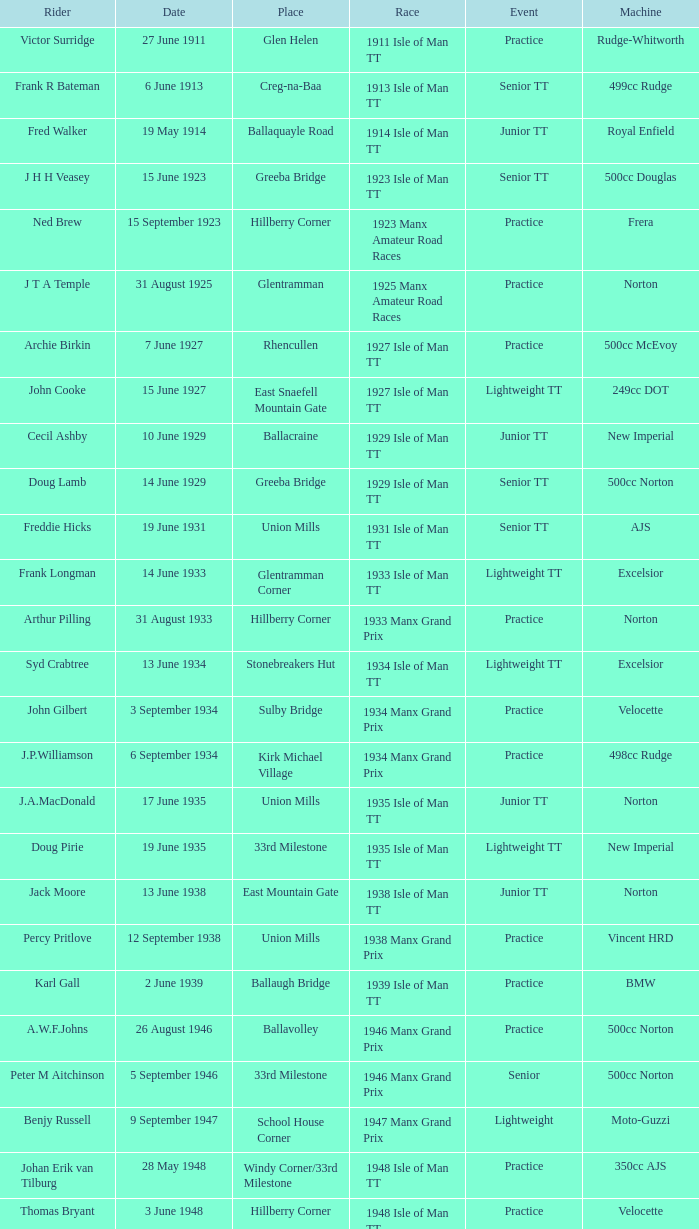What machine did Keith T. Gawler ride? 499cc Norton. 